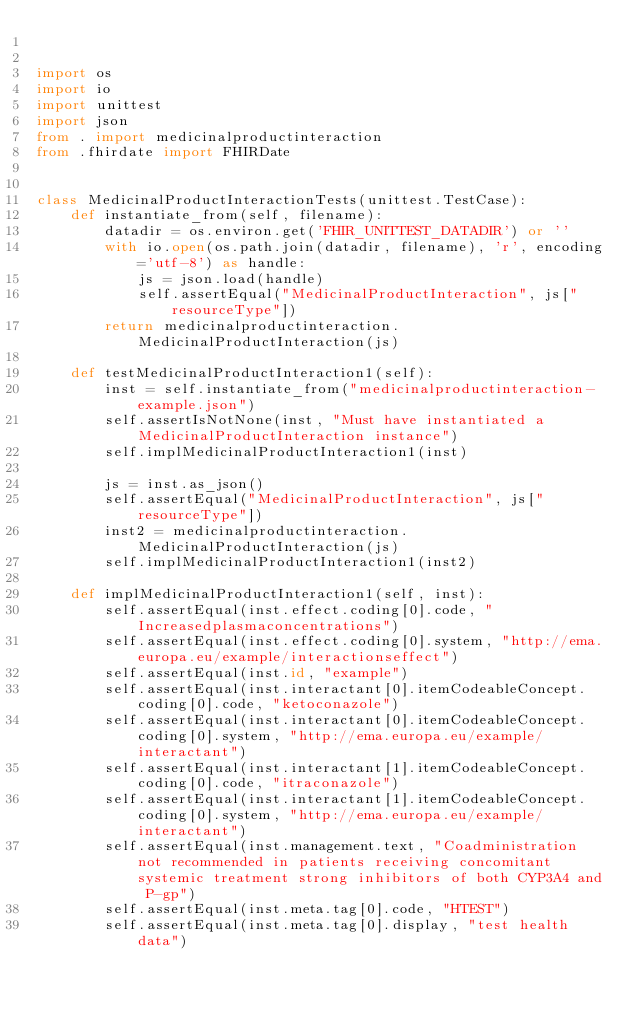<code> <loc_0><loc_0><loc_500><loc_500><_Python_>

import os
import io
import unittest
import json
from . import medicinalproductinteraction
from .fhirdate import FHIRDate


class MedicinalProductInteractionTests(unittest.TestCase):
    def instantiate_from(self, filename):
        datadir = os.environ.get('FHIR_UNITTEST_DATADIR') or ''
        with io.open(os.path.join(datadir, filename), 'r', encoding='utf-8') as handle:
            js = json.load(handle)
            self.assertEqual("MedicinalProductInteraction", js["resourceType"])
        return medicinalproductinteraction.MedicinalProductInteraction(js)
    
    def testMedicinalProductInteraction1(self):
        inst = self.instantiate_from("medicinalproductinteraction-example.json")
        self.assertIsNotNone(inst, "Must have instantiated a MedicinalProductInteraction instance")
        self.implMedicinalProductInteraction1(inst)
        
        js = inst.as_json()
        self.assertEqual("MedicinalProductInteraction", js["resourceType"])
        inst2 = medicinalproductinteraction.MedicinalProductInteraction(js)
        self.implMedicinalProductInteraction1(inst2)
    
    def implMedicinalProductInteraction1(self, inst):
        self.assertEqual(inst.effect.coding[0].code, "Increasedplasmaconcentrations")
        self.assertEqual(inst.effect.coding[0].system, "http://ema.europa.eu/example/interactionseffect")
        self.assertEqual(inst.id, "example")
        self.assertEqual(inst.interactant[0].itemCodeableConcept.coding[0].code, "ketoconazole")
        self.assertEqual(inst.interactant[0].itemCodeableConcept.coding[0].system, "http://ema.europa.eu/example/interactant")
        self.assertEqual(inst.interactant[1].itemCodeableConcept.coding[0].code, "itraconazole")
        self.assertEqual(inst.interactant[1].itemCodeableConcept.coding[0].system, "http://ema.europa.eu/example/interactant")
        self.assertEqual(inst.management.text, "Coadministration not recommended in patients receiving concomitant systemic treatment strong inhibitors of both CYP3A4 and P-gp")
        self.assertEqual(inst.meta.tag[0].code, "HTEST")
        self.assertEqual(inst.meta.tag[0].display, "test health data")</code> 